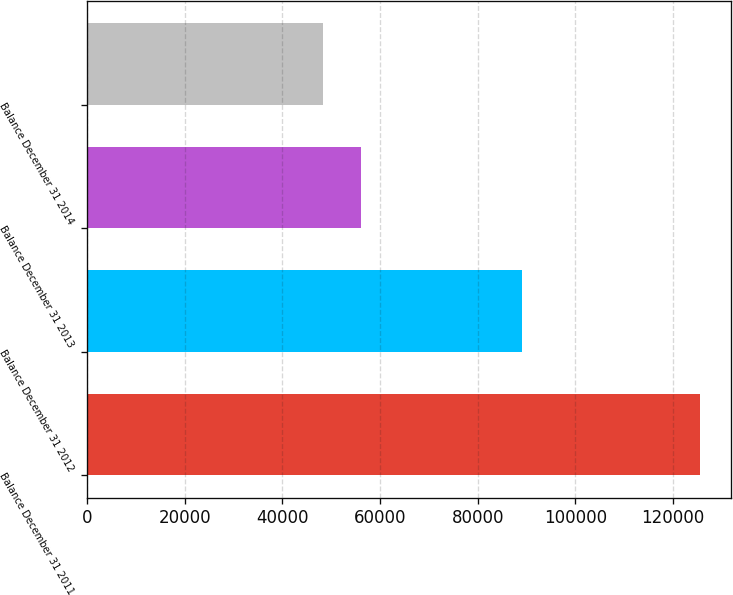Convert chart to OTSL. <chart><loc_0><loc_0><loc_500><loc_500><bar_chart><fcel>Balance December 31 2011<fcel>Balance December 31 2012<fcel>Balance December 31 2013<fcel>Balance December 31 2014<nl><fcel>125591<fcel>89095<fcel>56058.8<fcel>48333<nl></chart> 